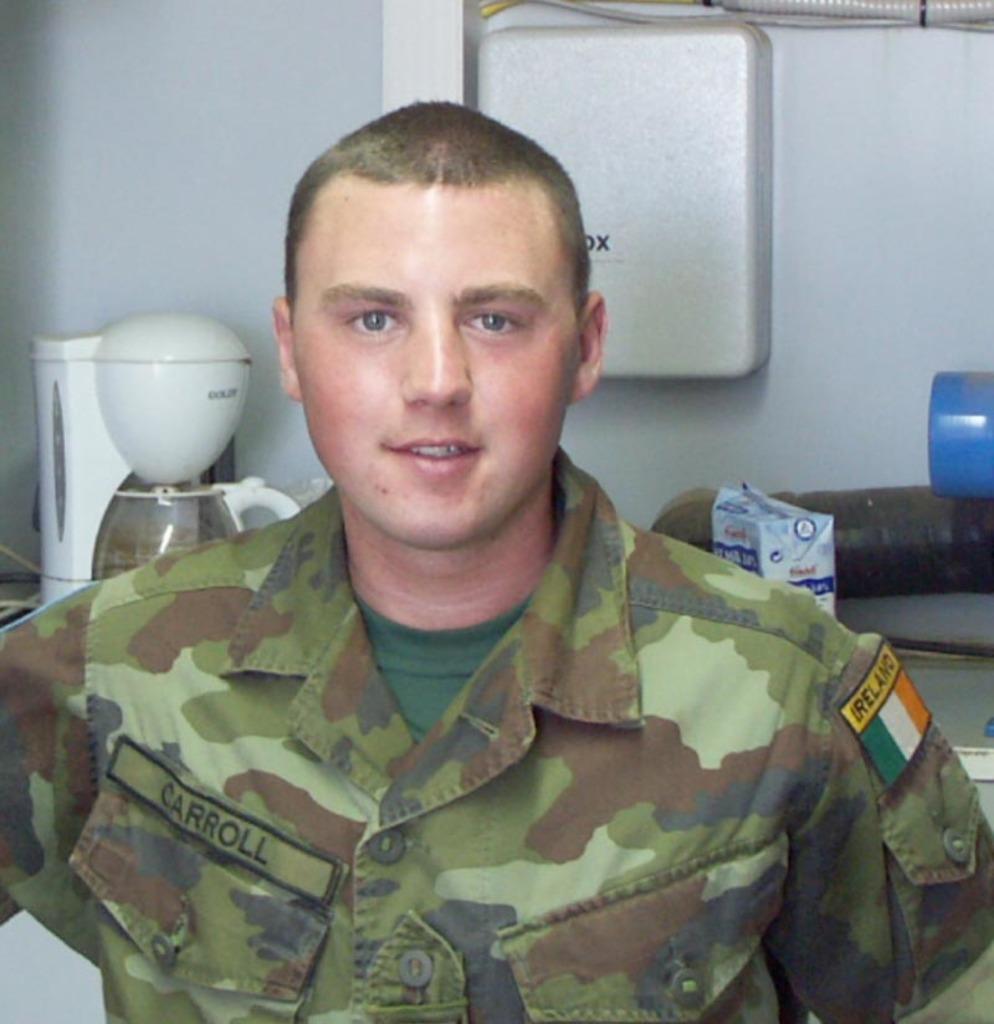What country does the flag on his sleeve come from?
Your answer should be compact. Ireland. What is the soldier's name?
Your answer should be compact. Carroll. 